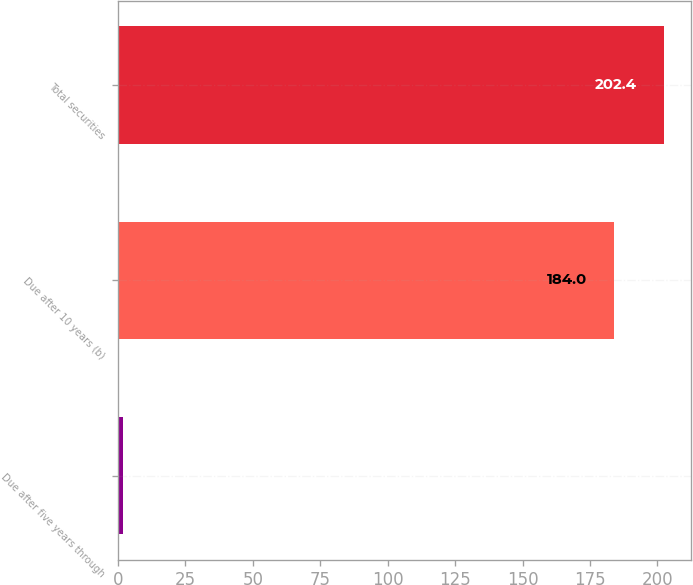Convert chart to OTSL. <chart><loc_0><loc_0><loc_500><loc_500><bar_chart><fcel>Due after five years through<fcel>Due after 10 years (b)<fcel>Total securities<nl><fcel>2<fcel>184<fcel>202.4<nl></chart> 